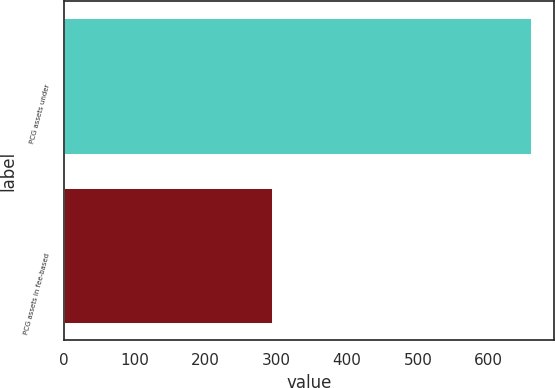<chart> <loc_0><loc_0><loc_500><loc_500><bar_chart><fcel>PCG assets under<fcel>PCG assets in fee-based<nl><fcel>659.5<fcel>294.5<nl></chart> 